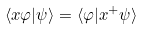<formula> <loc_0><loc_0><loc_500><loc_500>\langle x \varphi | \psi \rangle = \langle \varphi | x ^ { + } \psi \rangle</formula> 